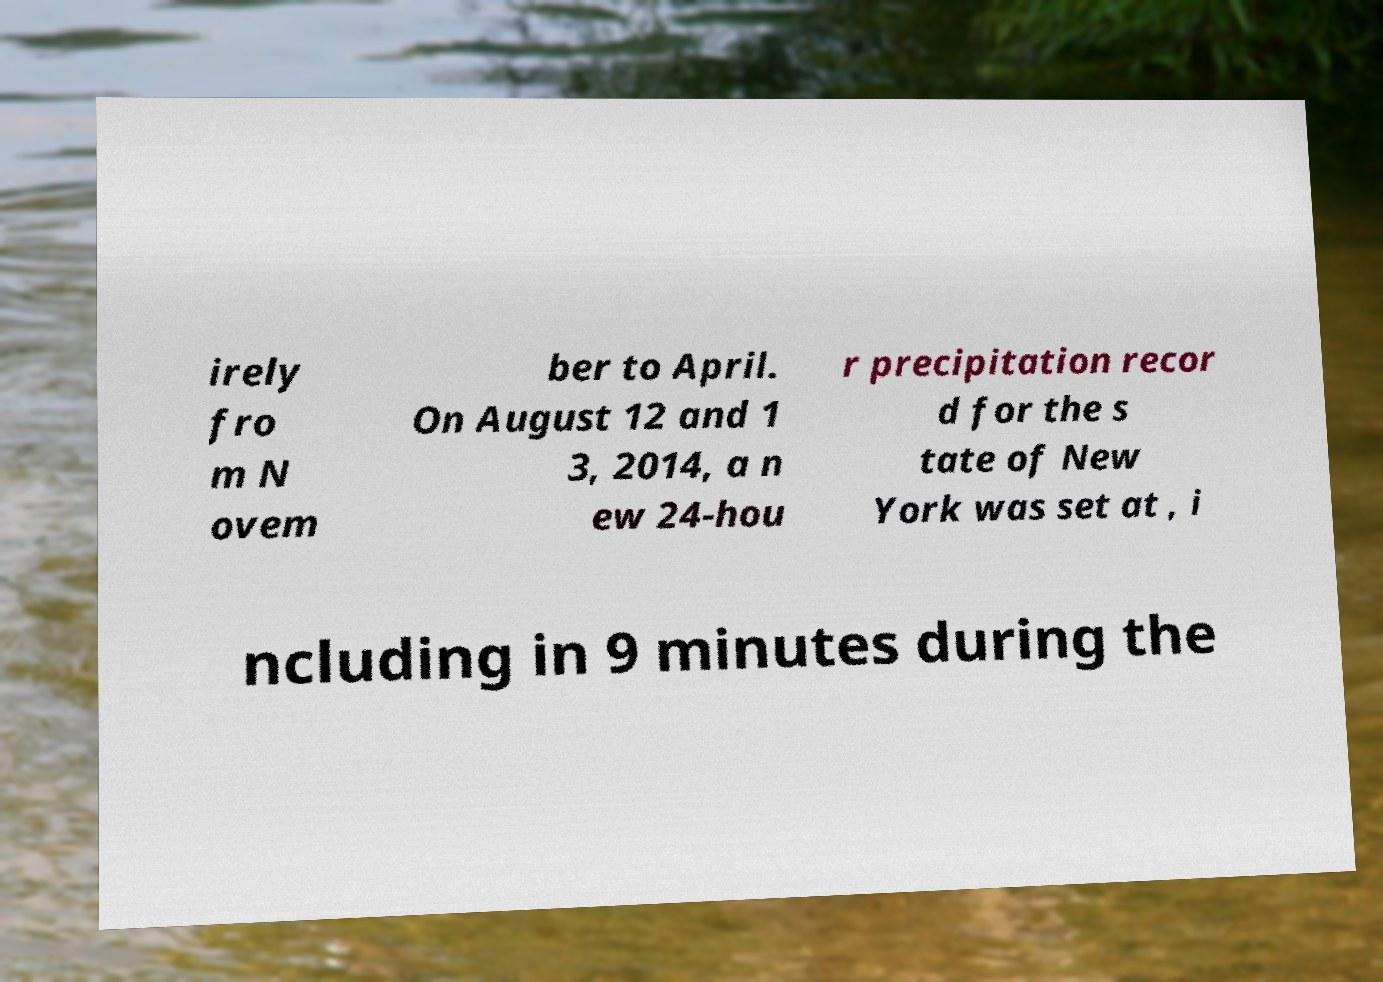Could you extract and type out the text from this image? irely fro m N ovem ber to April. On August 12 and 1 3, 2014, a n ew 24-hou r precipitation recor d for the s tate of New York was set at , i ncluding in 9 minutes during the 